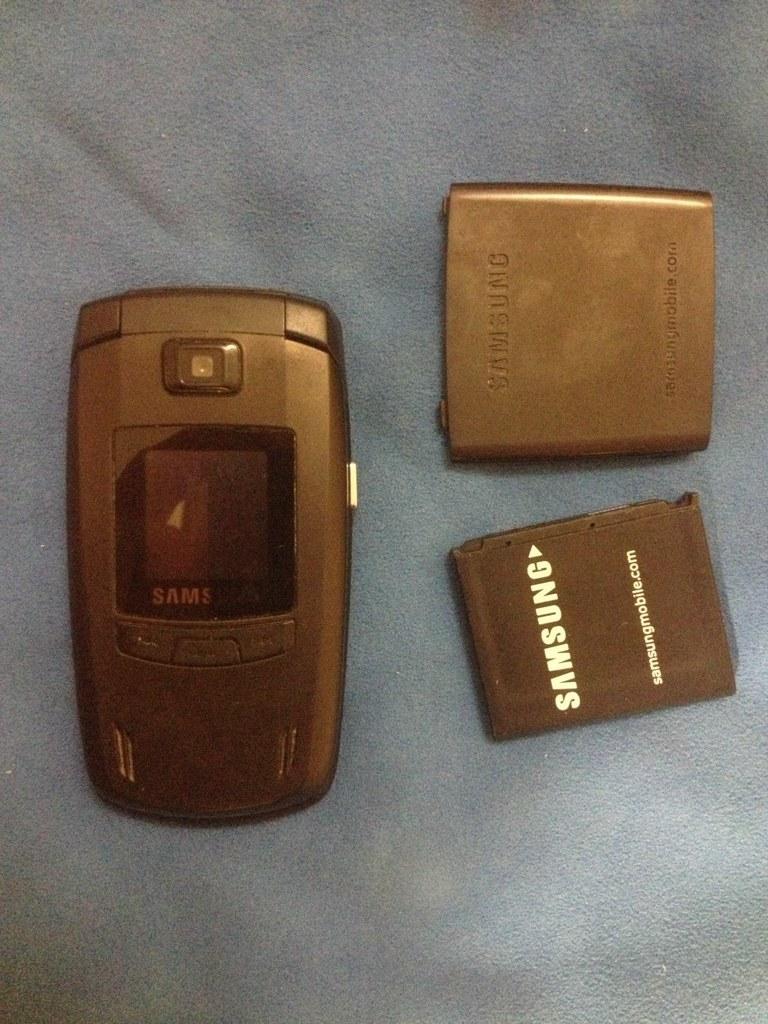What brand of battery is used for this phone?
Make the answer very short. Samsung. What is the website on the bettery?
Your response must be concise. Samsungmobile.com. 